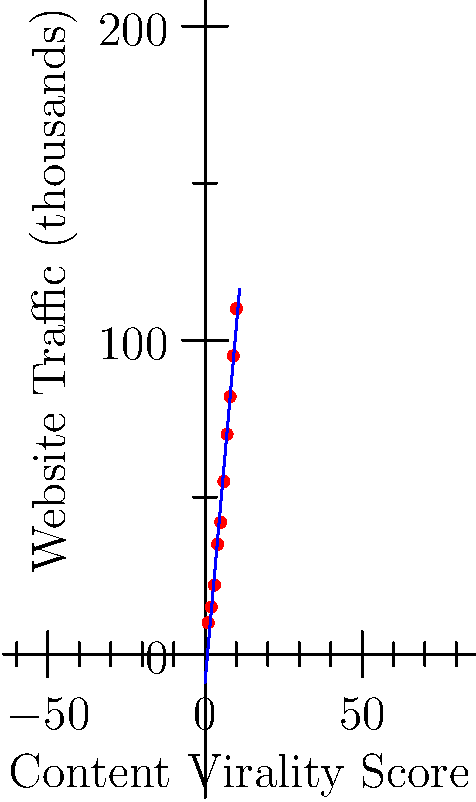As an independent researcher exploring the relationship between website traffic and content virality, you've collected data from 10 different websites. The scatter plot shows website traffic (in thousands of visitors) on the y-axis and a content virality score on the x-axis. Based on the trend line, what is the approximate increase in website traffic (in thousands) for every one-point increase in the content virality score? To answer this question, we need to analyze the trend line in the scatter plot. The slope of this line represents the average increase in website traffic for each unit increase in the content virality score. Here's how we can determine this:

1. Observe that the trend line is roughly linear, indicating a positive correlation between content virality and website traffic.

2. To estimate the slope, we can use the "rise over run" method:
   - Choose two points on the line, preferably far apart for better accuracy.
   - Let's use (1, 10) and (10, 110) as our approximate points.

3. Calculate the slope:
   $\text{Slope} = \frac{\text{Rise}}{\text{Run}} = \frac{\text{Change in y}}{\text{Change in x}}$

   $\text{Slope} = \frac{110 - 10}{10 - 1} = \frac{100}{9} \approx 11.11$

4. The slope of approximately 11.11 means that for every one-point increase in the content virality score, the website traffic increases by about 11,110 visitors (remember, the y-axis is in thousands).

5. Rounding to the nearest thousand, we get an increase of about 11,000 visitors per point increase in virality score.
Answer: 11,000 visitors 